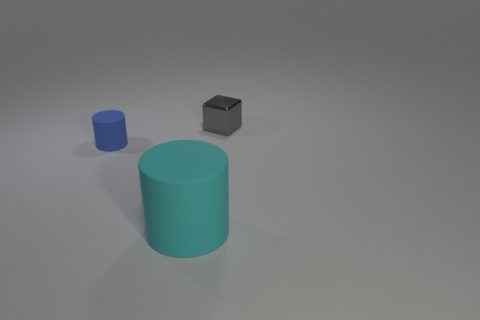What number of metallic things are either small cylinders or purple objects?
Ensure brevity in your answer.  0. How many other big matte cylinders are the same color as the big rubber cylinder?
Your response must be concise. 0. What is the material of the cylinder that is to the left of the rubber cylinder in front of the small object that is in front of the cube?
Your answer should be compact. Rubber. What color is the thing on the right side of the large thing in front of the blue cylinder?
Provide a succinct answer. Gray. How many big objects are yellow shiny cylinders or blue things?
Make the answer very short. 0. What number of big things have the same material as the gray cube?
Your answer should be compact. 0. There is a matte cylinder that is to the right of the small blue cylinder; what size is it?
Your answer should be compact. Large. There is a tiny object on the left side of the tiny object that is right of the large rubber cylinder; what is its shape?
Provide a succinct answer. Cylinder. There is a rubber object to the right of the small object in front of the gray object; what number of blocks are on the left side of it?
Your answer should be compact. 0. Is the number of tiny cylinders that are left of the large cyan thing less than the number of tiny blocks?
Provide a short and direct response. No. 